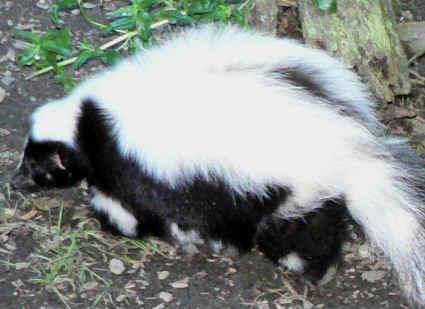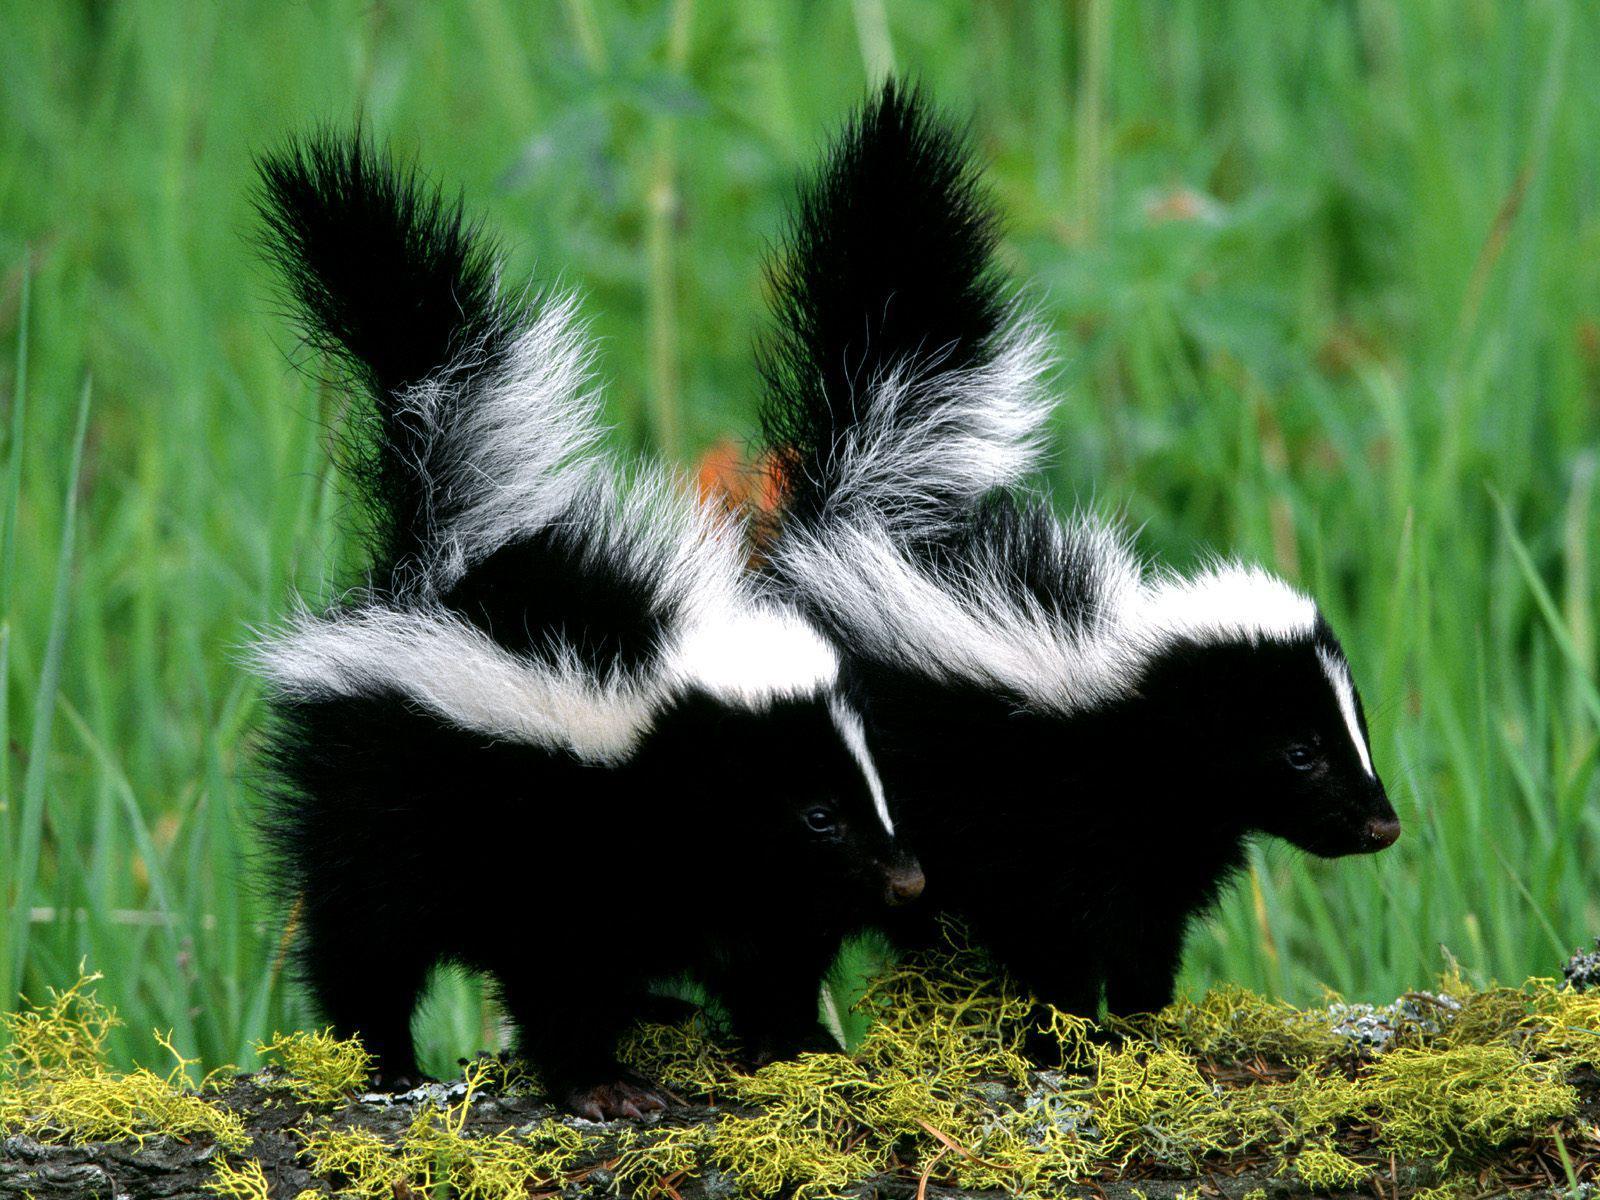The first image is the image on the left, the second image is the image on the right. Evaluate the accuracy of this statement regarding the images: "There are more than two skunks in total.". Is it true? Answer yes or no. Yes. The first image is the image on the left, the second image is the image on the right. Given the left and right images, does the statement "The right image includes at least two somewhat forward-angled side-by-side skunks with their tails up." hold true? Answer yes or no. Yes. 